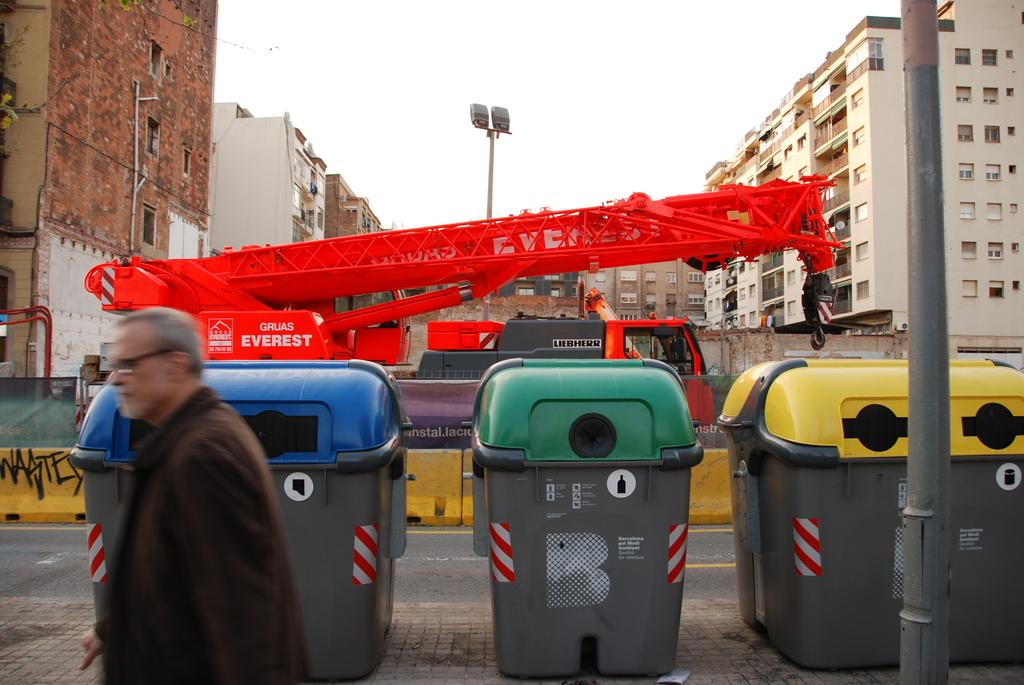Provide a one-sentence caption for the provided image. A large, red Everest construction machine is parked in a construction zone. 